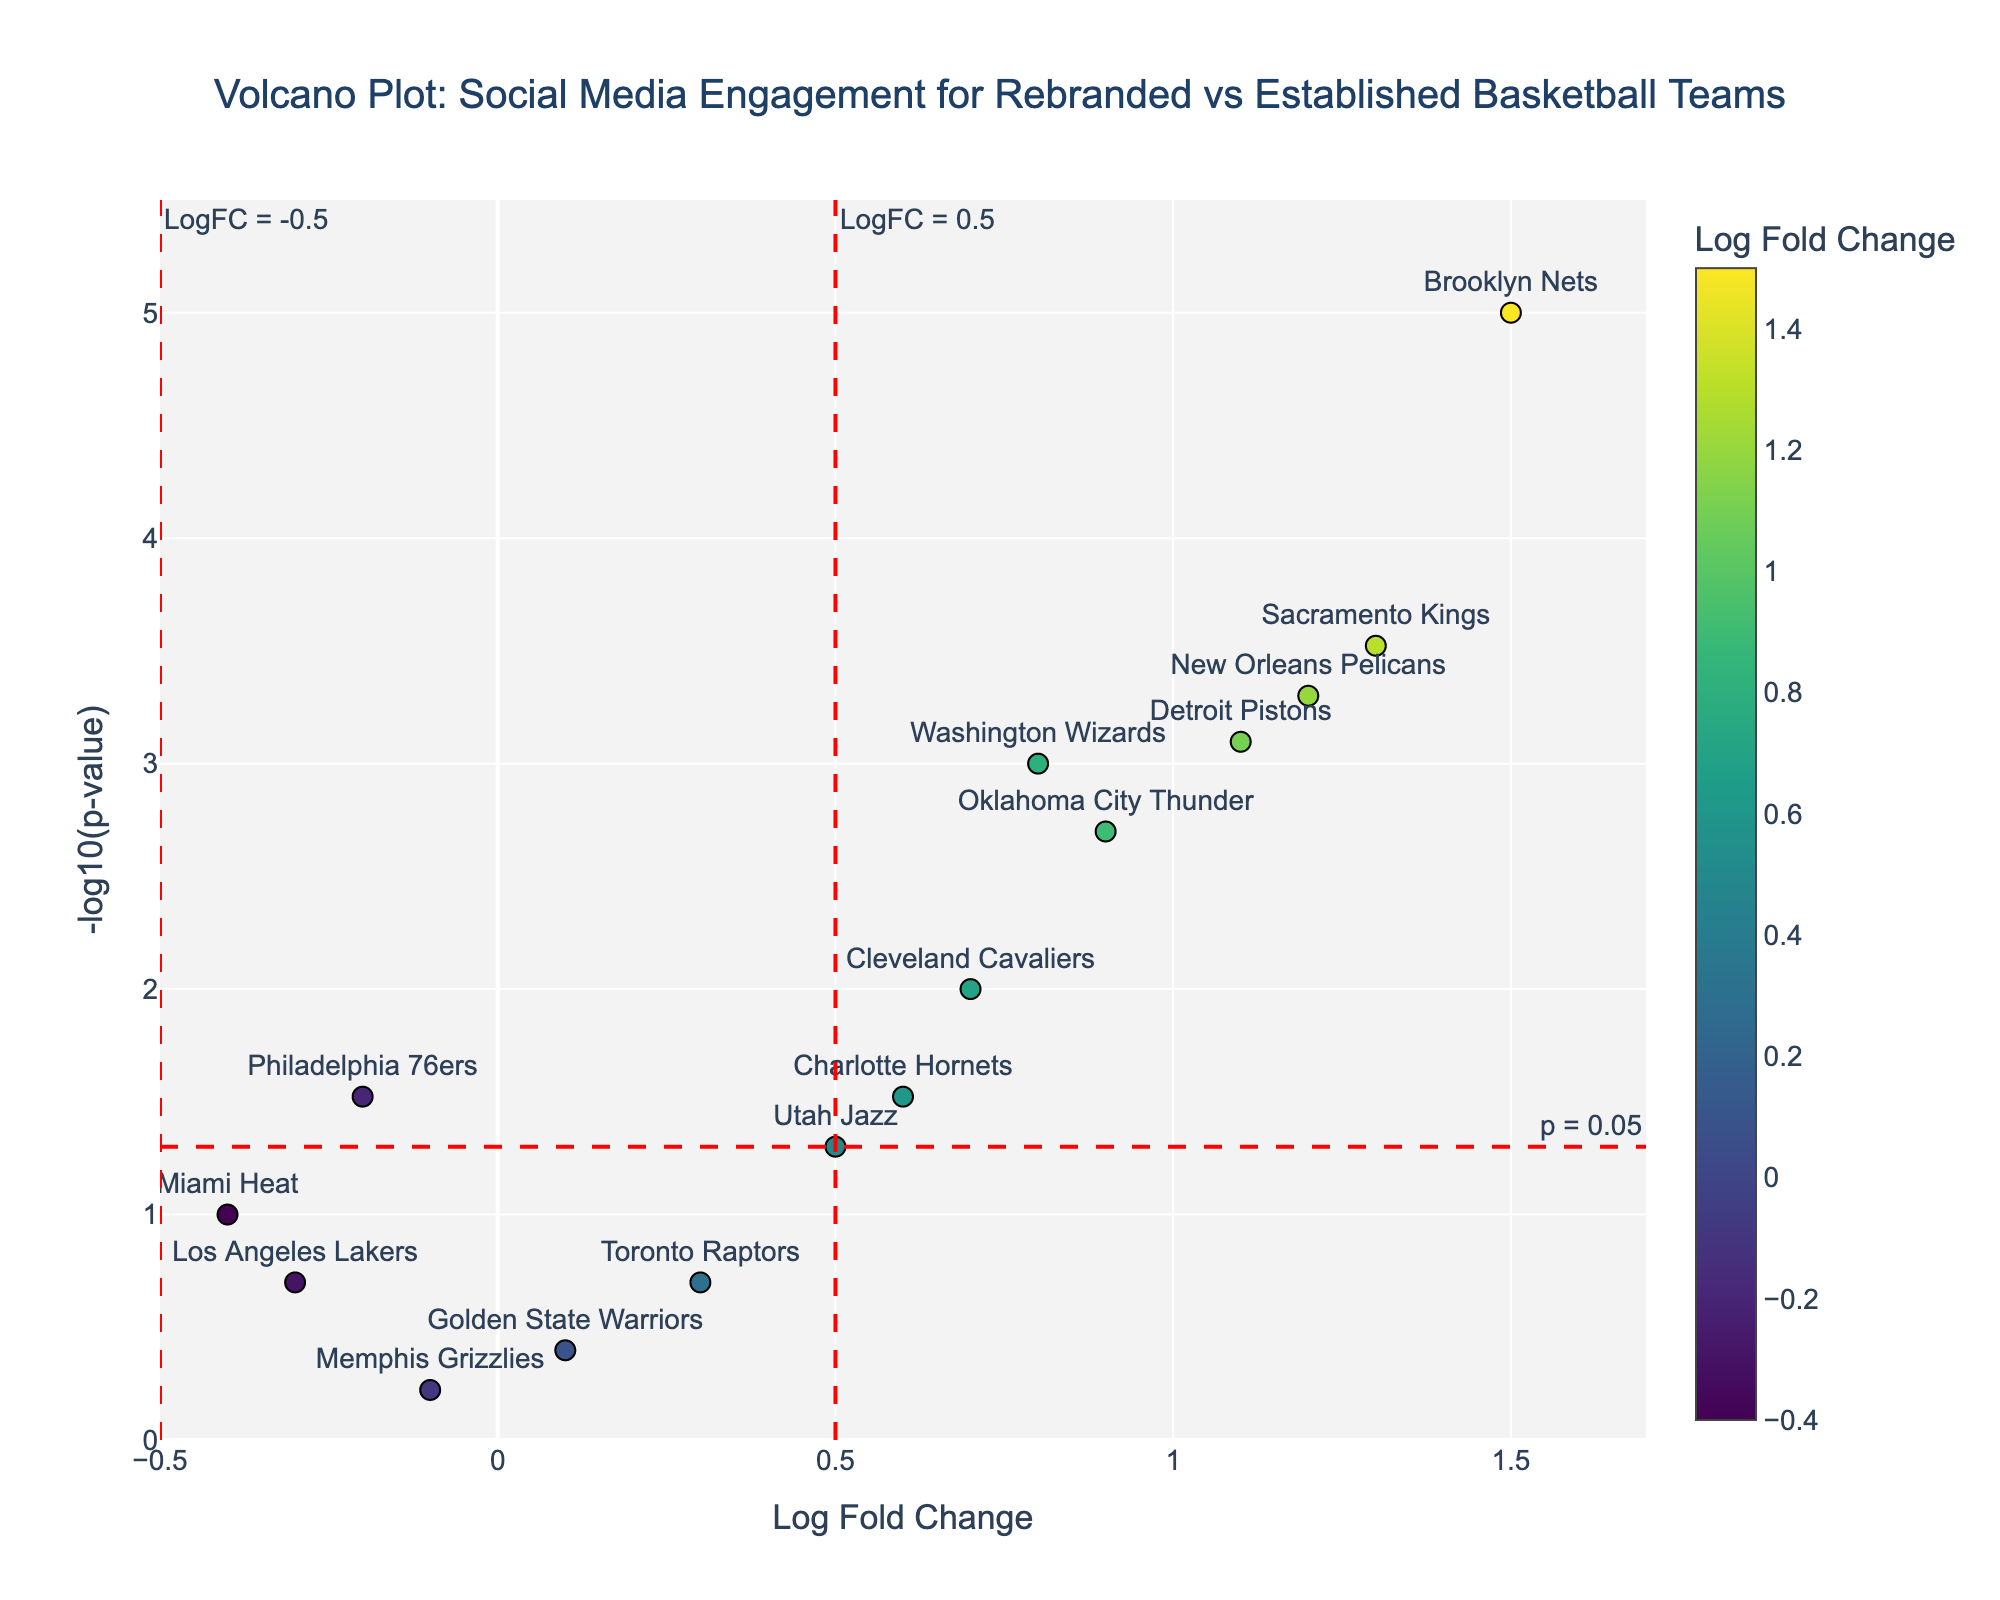What is the title of the figure? The title is prominently displayed at the top of the figure, telling us clearly what the plot represents.
Answer: Volcano Plot: Social Media Engagement for Rebranded vs Established Basketball Teams How many teams have a Log Fold Change greater than 0.5 and a p-value less than 0.05? First, identify the Log Fold Change threshold (0.5) and the p-value threshold (−log10(0.05) ≈ 1.3). Count the teams located to the right of 0.5 and above 1.3.
Answer: 6 Which team has the highest Log Fold Change? Look for the team with the highest x-axis value (Log Fold Change).
Answer: Brooklyn Nets What is the significance threshold for the p-value in the figure? The red dashed line marking the p-value significance threshold is annotated in the plot. It corresponds to −log10(0.05).
Answer: 0.05 Are there any teams with Log Fold Change values less than -0.5? Check the left side of the figure for any points to the left of -0.5.
Answer: No Which team has the lowest -log10(p-value)? Identify the point with the lowest y-axis value, which represents -log10(p-value).
Answer: Memphis Grizzlies How many total teams are represented in the plot? Count all the data points present in the figure.
Answer: 14 Compare the Log Fold Change and -log10(p-value) of the Cleveland Cavaliers and Charlotte Hornets. Which team has higher engagement metrics? First, compare Log Fold Change (x-values) then compare -log10(p-value) (y-values) for both teams.
Answer: Cleveland Cavaliers What does a point located at the top right corner of the volcano plot indicate about the team's social media engagement? A point at the top right indicates high Log Fold Change and low p-value, suggesting significantly high engagement metrics.
Answer: High engagement metrics Do the Los Angeles Lakers show a significant change in social media engagement? Check if the point representing the Los Angeles Lakers lies above the −log10(0.05) threshold line. Also, note the Log Fold Change value if it's large.
Answer: No 